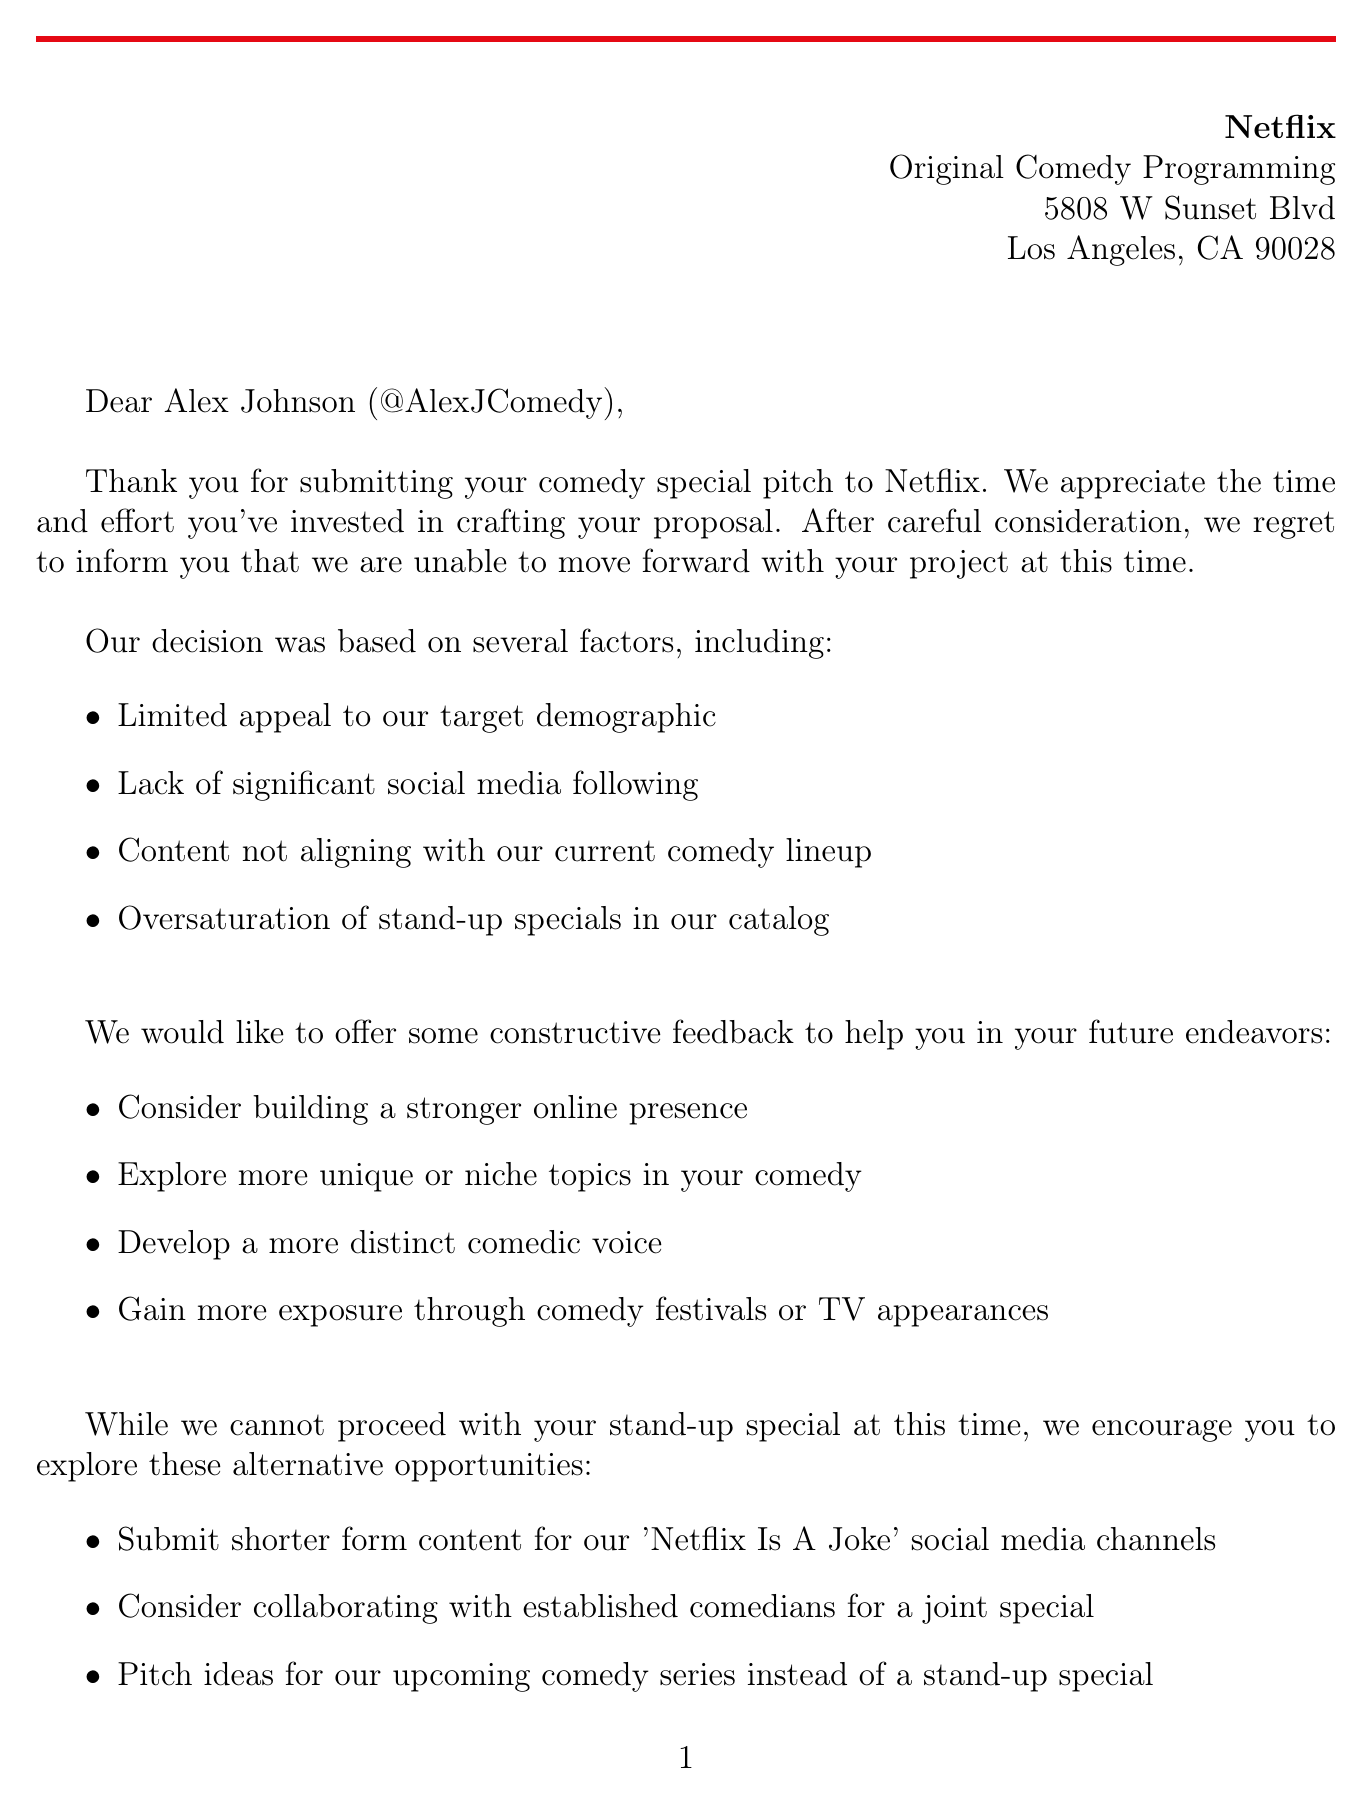What is the name of the comedian? The document addresses the submission to a comedian named Alex Johnson.
Answer: Alex Johnson What is the social media handle of the comedian? The letter mentions the comedian's social media handle as part of the salutation.
Answer: @AlexJComedy Which streaming platform sent the rejection letter? The header of the letter clearly states the name of the streaming platform.
Answer: Netflix What is one of the rejection reasons? The document lists several reasons for the rejection in a bulleted format.
Answer: Limited appeal to our target demographic Who is the Senior Content Acquisition Manager? The closing section of the letter provides the name and title of the person signing off.
Answer: Sarah Thompson What alternative opportunity does Netflix suggest? The letter mentions several alternative opportunities, one of which can be highlighted.
Answer: Submit shorter form content for our 'Netflix Is A Joke' social media channels Which comedy platform is noted as a competitor? The document includes a list of competitors affecting the comedy landscape.
Answer: YouTube's growing comedy content What industry trend mentioned in the letter is currently affecting comedy? The letter outlines several industry trends impacting comedy content today.
Answer: Increased demand for diverse voices in comedy What is a piece of constructive feedback given to the comedian? The document includes suggested feedback for the comedian's future efforts.
Answer: Consider building a stronger online presence 